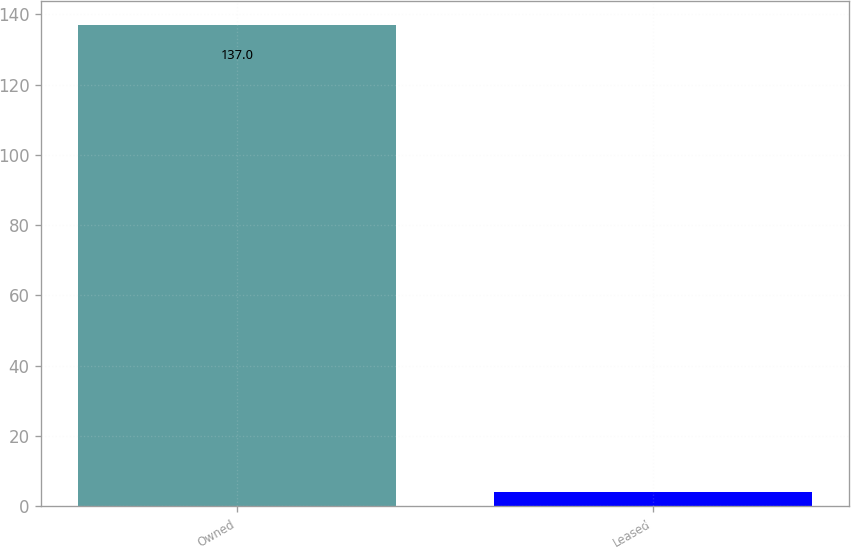Convert chart to OTSL. <chart><loc_0><loc_0><loc_500><loc_500><bar_chart><fcel>Owned<fcel>Leased<nl><fcel>137<fcel>4<nl></chart> 